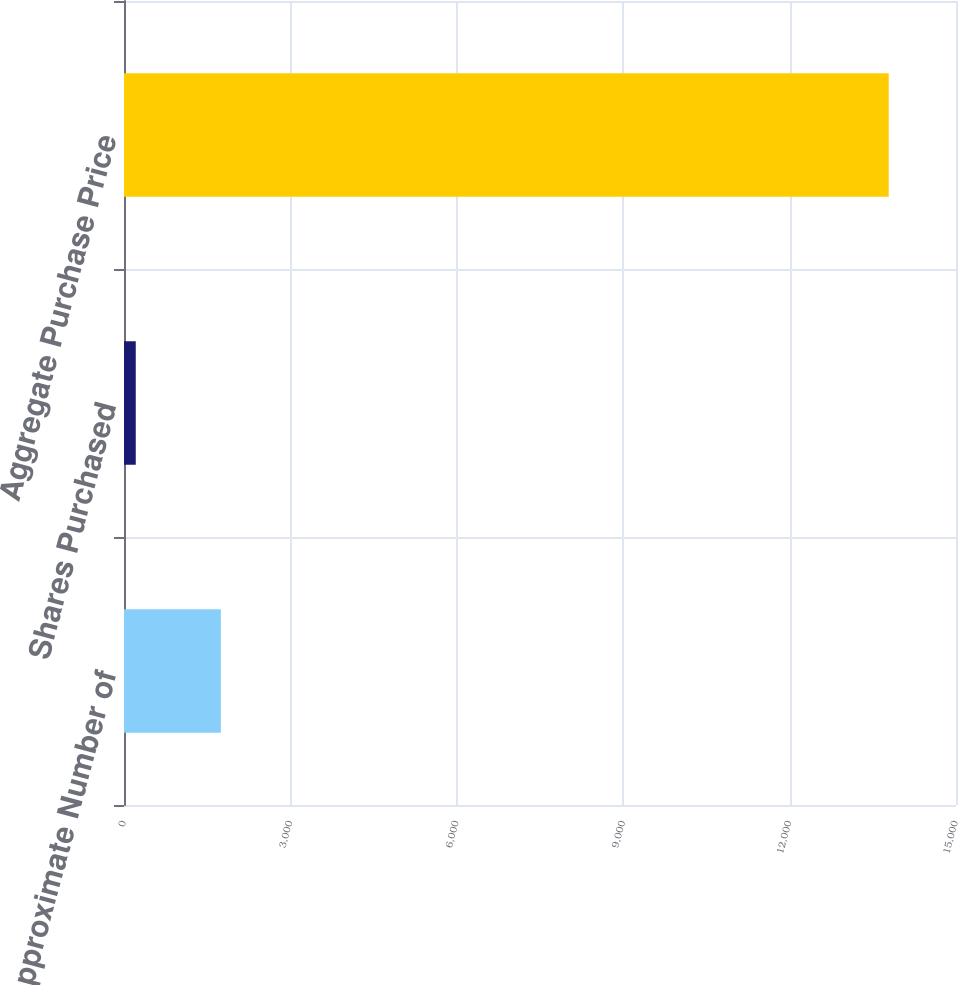Convert chart to OTSL. <chart><loc_0><loc_0><loc_500><loc_500><bar_chart><fcel>Approximate Number of<fcel>Shares Purchased<fcel>Aggregate Purchase Price<nl><fcel>1746<fcel>212<fcel>13787<nl></chart> 